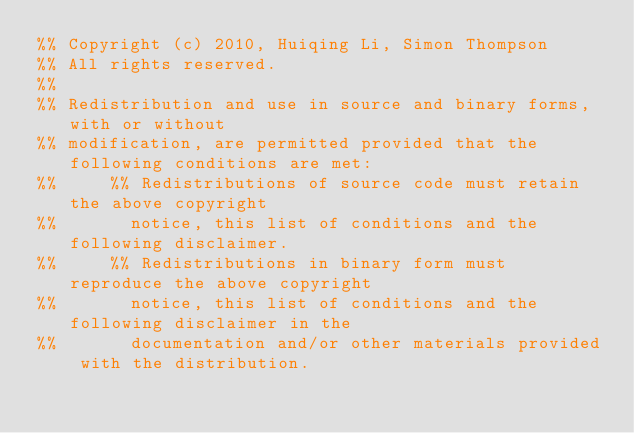<code> <loc_0><loc_0><loc_500><loc_500><_Erlang_>%% Copyright (c) 2010, Huiqing Li, Simon Thompson
%% All rights reserved.
%%
%% Redistribution and use in source and binary forms, with or without
%% modification, are permitted provided that the following conditions are met:
%%     %% Redistributions of source code must retain the above copyright
%%       notice, this list of conditions and the following disclaimer.
%%     %% Redistributions in binary form must reproduce the above copyright
%%       notice, this list of conditions and the following disclaimer in the
%%       documentation and/or other materials provided with the distribution.</code> 